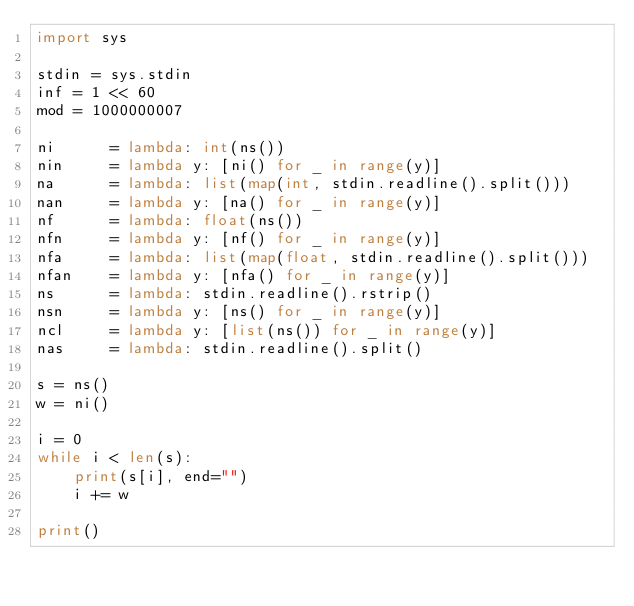Convert code to text. <code><loc_0><loc_0><loc_500><loc_500><_Python_>import sys

stdin = sys.stdin
inf = 1 << 60
mod = 1000000007

ni      = lambda: int(ns())
nin     = lambda y: [ni() for _ in range(y)]
na      = lambda: list(map(int, stdin.readline().split()))
nan     = lambda y: [na() for _ in range(y)]
nf      = lambda: float(ns())
nfn     = lambda y: [nf() for _ in range(y)]
nfa     = lambda: list(map(float, stdin.readline().split()))
nfan    = lambda y: [nfa() for _ in range(y)]
ns      = lambda: stdin.readline().rstrip()
nsn     = lambda y: [ns() for _ in range(y)]
ncl     = lambda y: [list(ns()) for _ in range(y)]
nas     = lambda: stdin.readline().split()

s = ns()
w = ni()

i = 0
while i < len(s):
    print(s[i], end="")
    i += w

print()</code> 